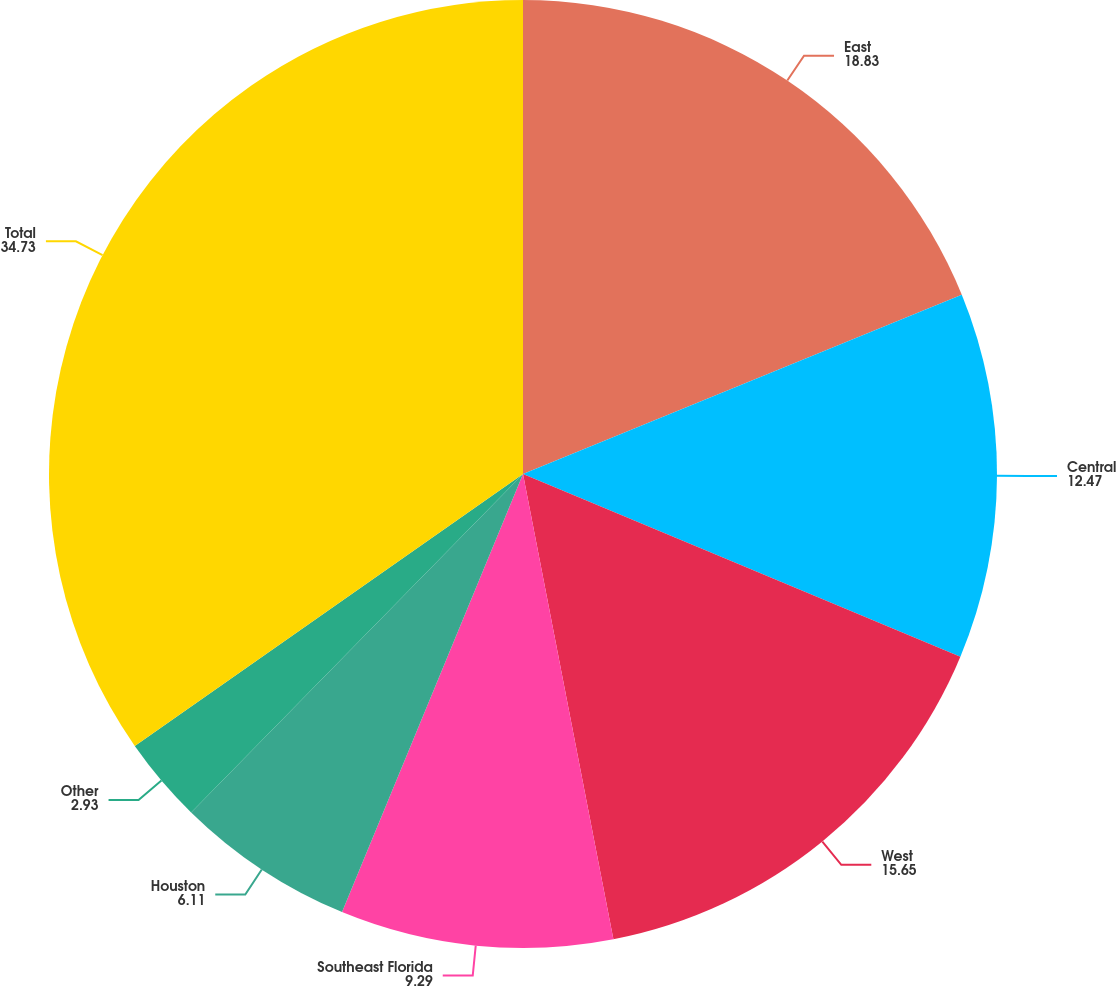<chart> <loc_0><loc_0><loc_500><loc_500><pie_chart><fcel>East<fcel>Central<fcel>West<fcel>Southeast Florida<fcel>Houston<fcel>Other<fcel>Total<nl><fcel>18.83%<fcel>12.47%<fcel>15.65%<fcel>9.29%<fcel>6.11%<fcel>2.93%<fcel>34.73%<nl></chart> 